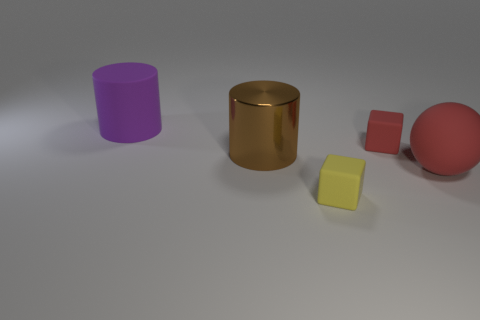Add 5 tiny yellow blocks. How many objects exist? 10 Subtract all balls. How many objects are left? 4 Subtract 0 blue cubes. How many objects are left? 5 Subtract all red blocks. Subtract all small yellow rubber blocks. How many objects are left? 3 Add 3 red spheres. How many red spheres are left? 4 Add 3 big purple metallic blocks. How many big purple metallic blocks exist? 3 